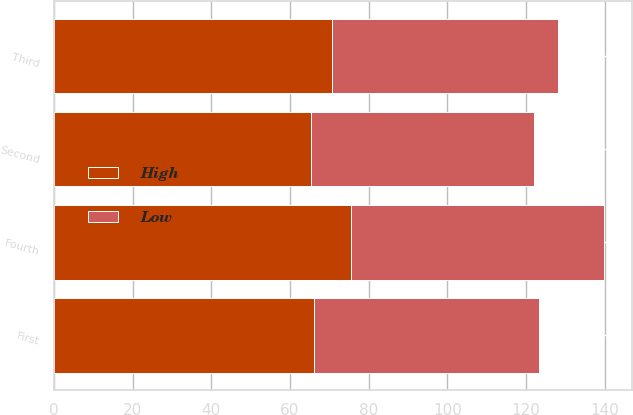Convert chart to OTSL. <chart><loc_0><loc_0><loc_500><loc_500><stacked_bar_chart><ecel><fcel>First<fcel>Second<fcel>Third<fcel>Fourth<nl><fcel>High<fcel>66.02<fcel>65.31<fcel>70.71<fcel>75.6<nl><fcel>Low<fcel>57.26<fcel>56.73<fcel>57.3<fcel>64.28<nl></chart> 